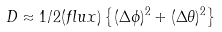Convert formula to latex. <formula><loc_0><loc_0><loc_500><loc_500>D \approx 1 / 2 ( f l u x ) \left \{ ( \Delta \phi ) ^ { 2 } + ( \Delta \theta ) ^ { 2 } \right \}</formula> 